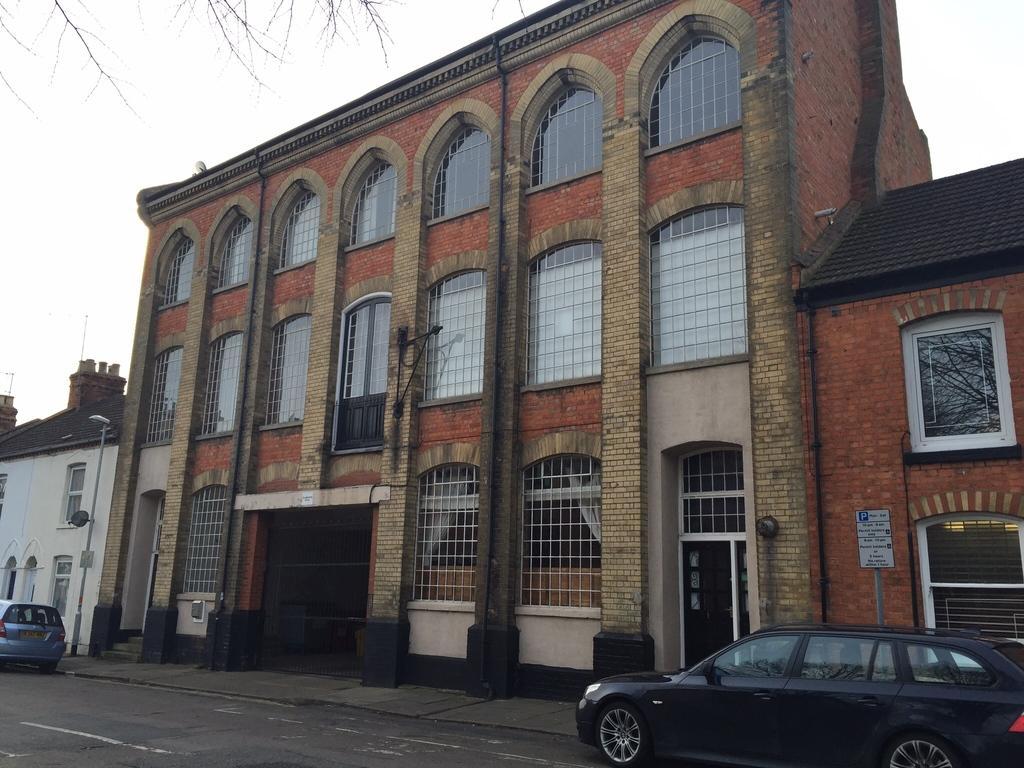In one or two sentences, can you explain what this image depicts? In this image I can see a road in the front and on it I can see two cars. In the background I can see three buildings and in the front of it I can see two poles, a street light, two boards and on these boards I can see something is written. I can also see number of windows and on the top left side of this image I can see few stems of a tree. 